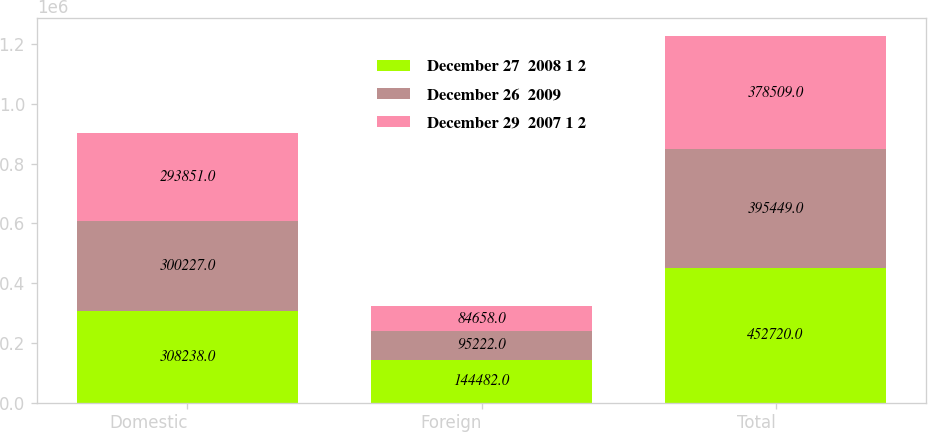Convert chart to OTSL. <chart><loc_0><loc_0><loc_500><loc_500><stacked_bar_chart><ecel><fcel>Domestic<fcel>Foreign<fcel>Total<nl><fcel>December 27  2008 1 2<fcel>308238<fcel>144482<fcel>452720<nl><fcel>December 26  2009<fcel>300227<fcel>95222<fcel>395449<nl><fcel>December 29  2007 1 2<fcel>293851<fcel>84658<fcel>378509<nl></chart> 